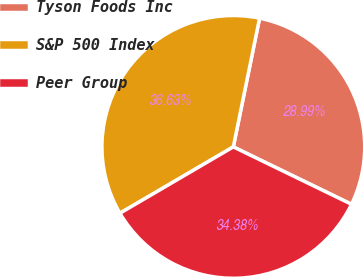Convert chart to OTSL. <chart><loc_0><loc_0><loc_500><loc_500><pie_chart><fcel>Tyson Foods Inc<fcel>S&P 500 Index<fcel>Peer Group<nl><fcel>28.99%<fcel>36.63%<fcel>34.38%<nl></chart> 